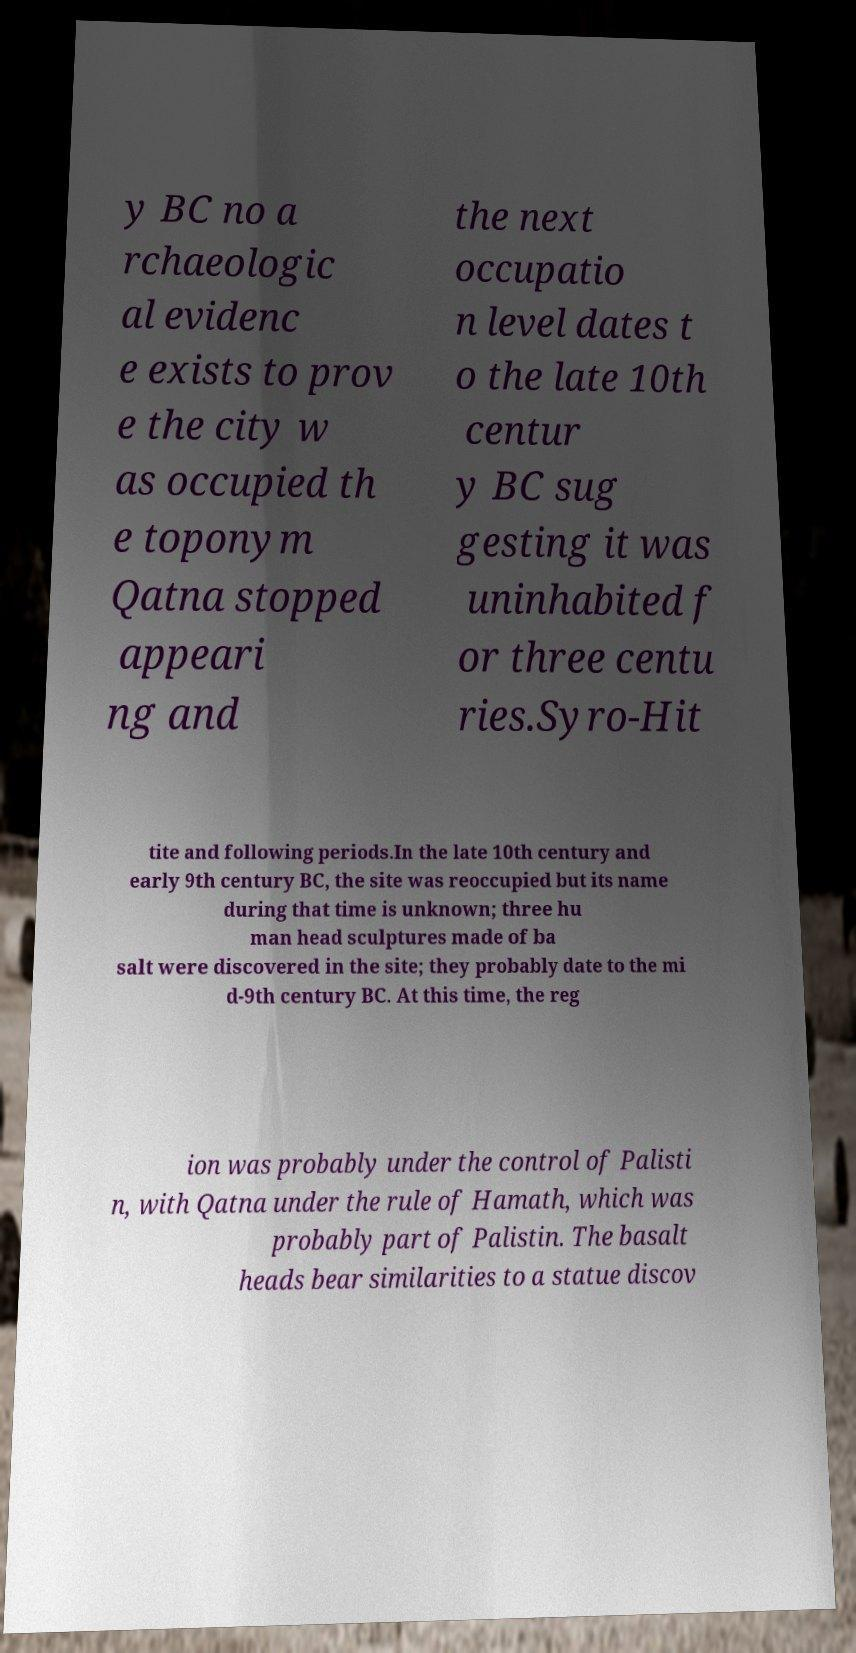Please read and relay the text visible in this image. What does it say? y BC no a rchaeologic al evidenc e exists to prov e the city w as occupied th e toponym Qatna stopped appeari ng and the next occupatio n level dates t o the late 10th centur y BC sug gesting it was uninhabited f or three centu ries.Syro-Hit tite and following periods.In the late 10th century and early 9th century BC, the site was reoccupied but its name during that time is unknown; three hu man head sculptures made of ba salt were discovered in the site; they probably date to the mi d-9th century BC. At this time, the reg ion was probably under the control of Palisti n, with Qatna under the rule of Hamath, which was probably part of Palistin. The basalt heads bear similarities to a statue discov 